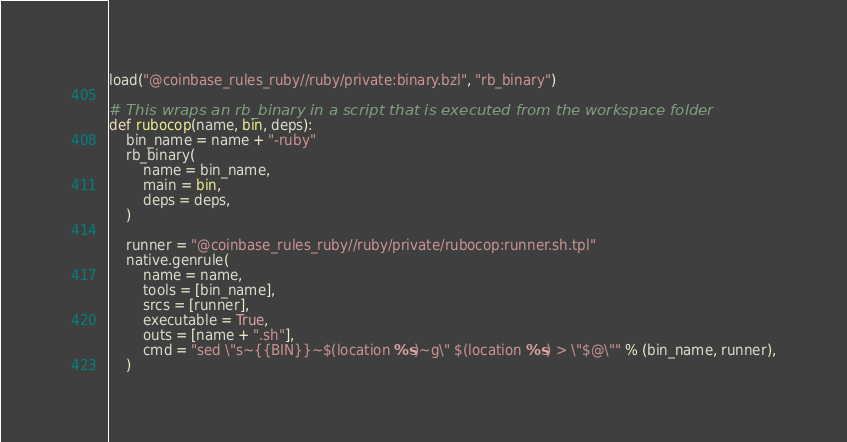Convert code to text. <code><loc_0><loc_0><loc_500><loc_500><_Python_>load("@coinbase_rules_ruby//ruby/private:binary.bzl", "rb_binary")

# This wraps an rb_binary in a script that is executed from the workspace folder
def rubocop(name, bin, deps):
    bin_name = name + "-ruby"
    rb_binary(
        name = bin_name,
        main = bin,
        deps = deps,
    )

    runner = "@coinbase_rules_ruby//ruby/private/rubocop:runner.sh.tpl"
    native.genrule(
        name = name,
        tools = [bin_name],
        srcs = [runner],
        executable = True,
        outs = [name + ".sh"],
        cmd = "sed \"s~{{BIN}}~$(location %s)~g\" $(location %s) > \"$@\"" % (bin_name, runner),
    )
</code> 